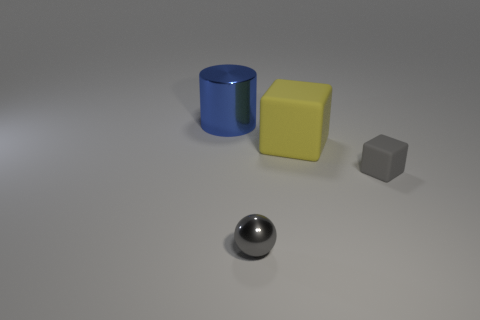What could be the purpose of depicting these objects together in this way? Such depictions are often used in visual and design fields to either showcase different geometric forms and colors or to create a controlled setting for testing visual perception, lighting effects, or the interplay of shadows. Educators and artists might also use this arrangement to teach or exhibit fundamental principles of shape, color theory, and composition. 